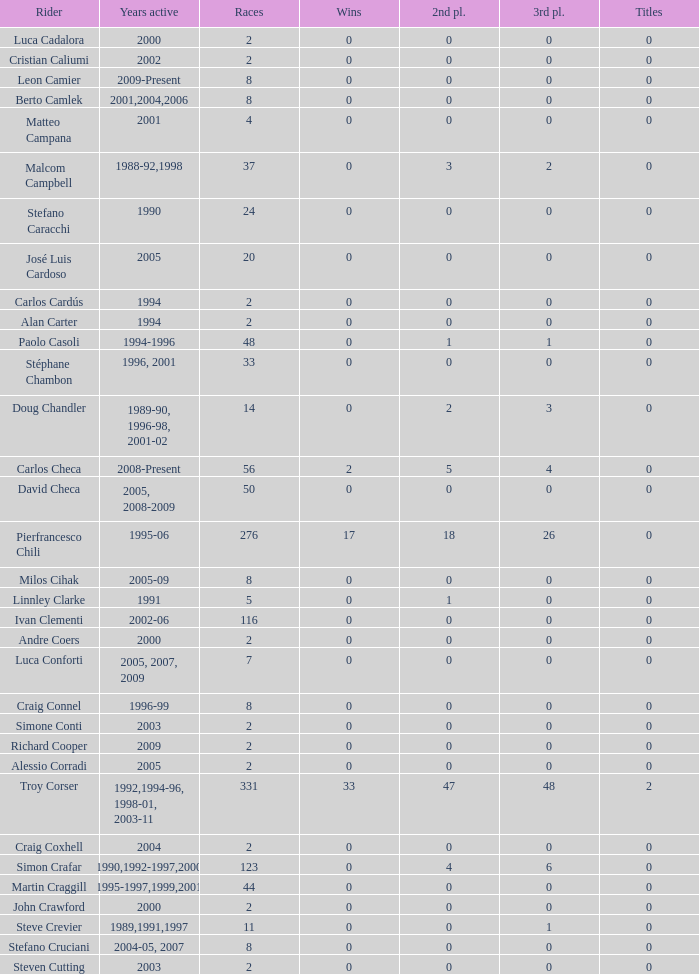What is the overall count of victories for riders who have participated in less than 56 races and won at least one title? 0.0. 